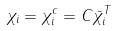<formula> <loc_0><loc_0><loc_500><loc_500>\chi _ { i } = \chi _ { i } ^ { c } = C \bar { \chi } _ { i } ^ { T }</formula> 